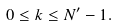Convert formula to latex. <formula><loc_0><loc_0><loc_500><loc_500>0 \leq k \leq N ^ { \prime } - 1 .</formula> 